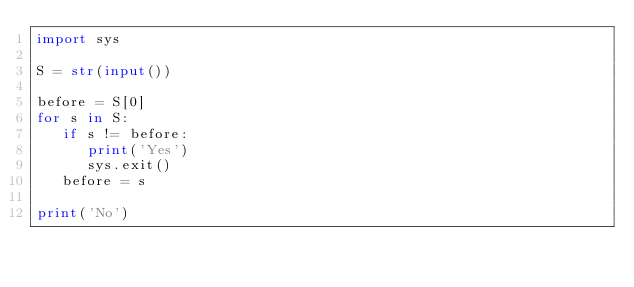<code> <loc_0><loc_0><loc_500><loc_500><_Python_>import sys

S = str(input())

before = S[0]
for s in S:
   if s != before:
      print('Yes')
      sys.exit()
   before = s

print('No')</code> 